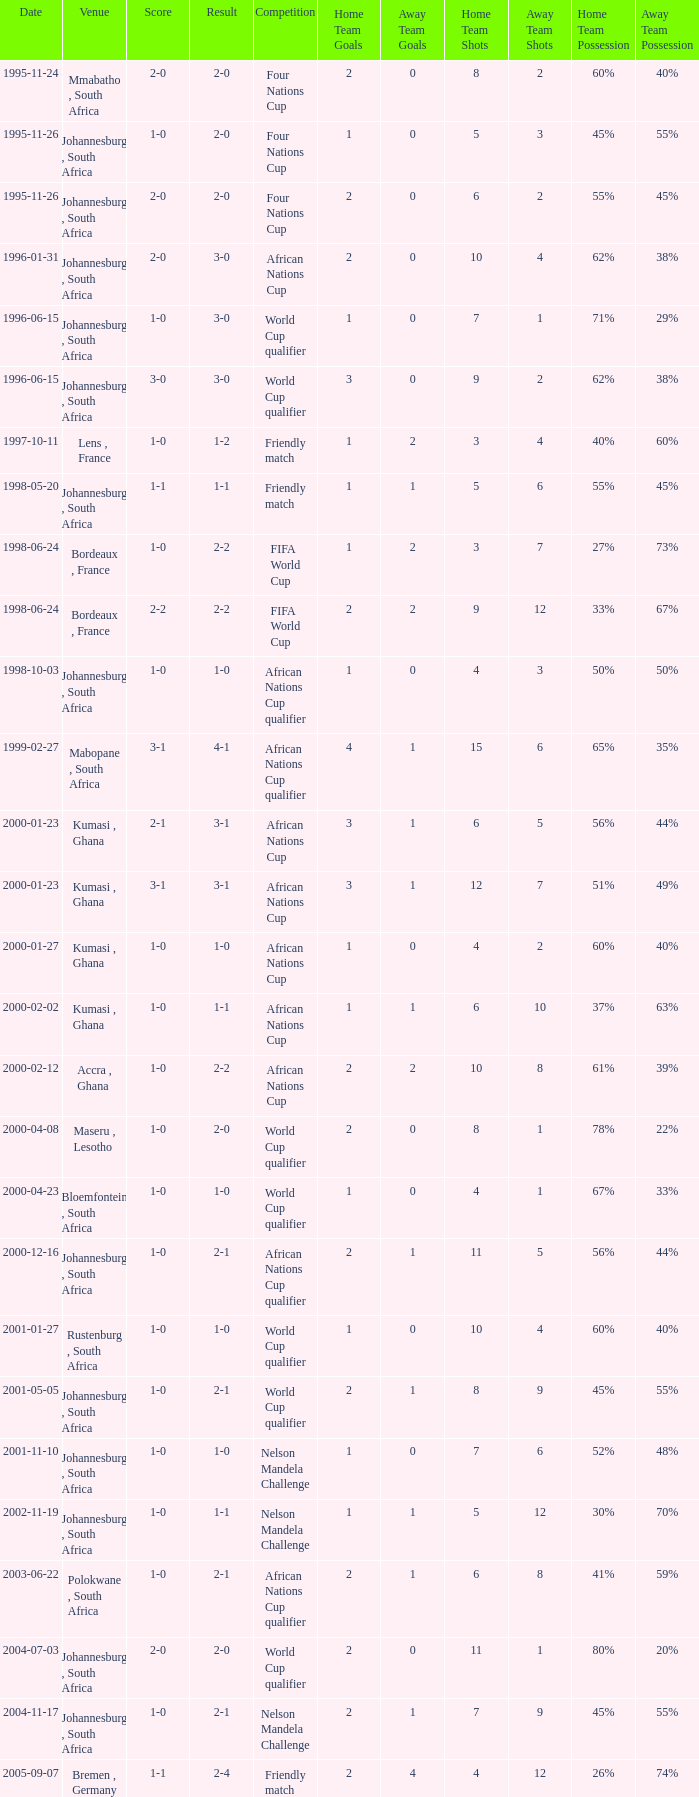What is the Venue of the Competition on 2001-05-05? Johannesburg , South Africa. 